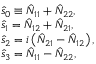<formula> <loc_0><loc_0><loc_500><loc_500>\begin{array} { r l } & { \hat { s } _ { 0 } \equiv \hat { N } _ { 1 1 } + \hat { N } _ { 2 2 } , } \\ & { \hat { s } _ { 1 } = \hat { N } _ { 1 2 } + \hat { N } _ { 2 1 } , } \\ & { \hat { s } _ { 2 } = i \left ( \hat { N } _ { 2 1 } - \hat { N } _ { 1 2 } \right ) , } \\ & { \hat { s } _ { 3 } = \hat { N } _ { 1 1 } - \hat { N } _ { 2 2 } , } \end{array}</formula> 